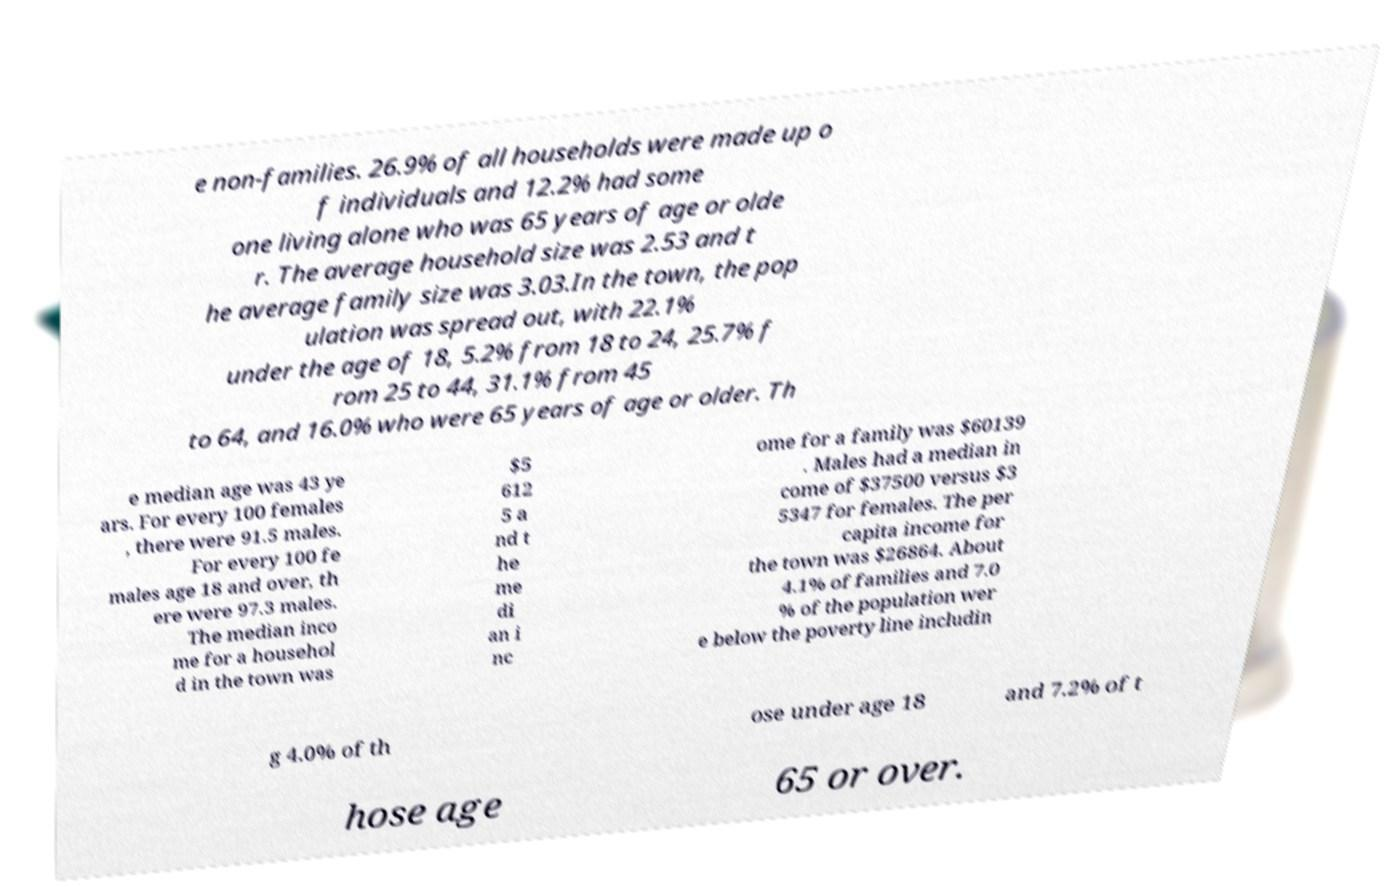Please read and relay the text visible in this image. What does it say? e non-families. 26.9% of all households were made up o f individuals and 12.2% had some one living alone who was 65 years of age or olde r. The average household size was 2.53 and t he average family size was 3.03.In the town, the pop ulation was spread out, with 22.1% under the age of 18, 5.2% from 18 to 24, 25.7% f rom 25 to 44, 31.1% from 45 to 64, and 16.0% who were 65 years of age or older. Th e median age was 43 ye ars. For every 100 females , there were 91.5 males. For every 100 fe males age 18 and over, th ere were 97.3 males. The median inco me for a househol d in the town was $5 612 5 a nd t he me di an i nc ome for a family was $60139 . Males had a median in come of $37500 versus $3 5347 for females. The per capita income for the town was $26864. About 4.1% of families and 7.0 % of the population wer e below the poverty line includin g 4.0% of th ose under age 18 and 7.2% of t hose age 65 or over. 